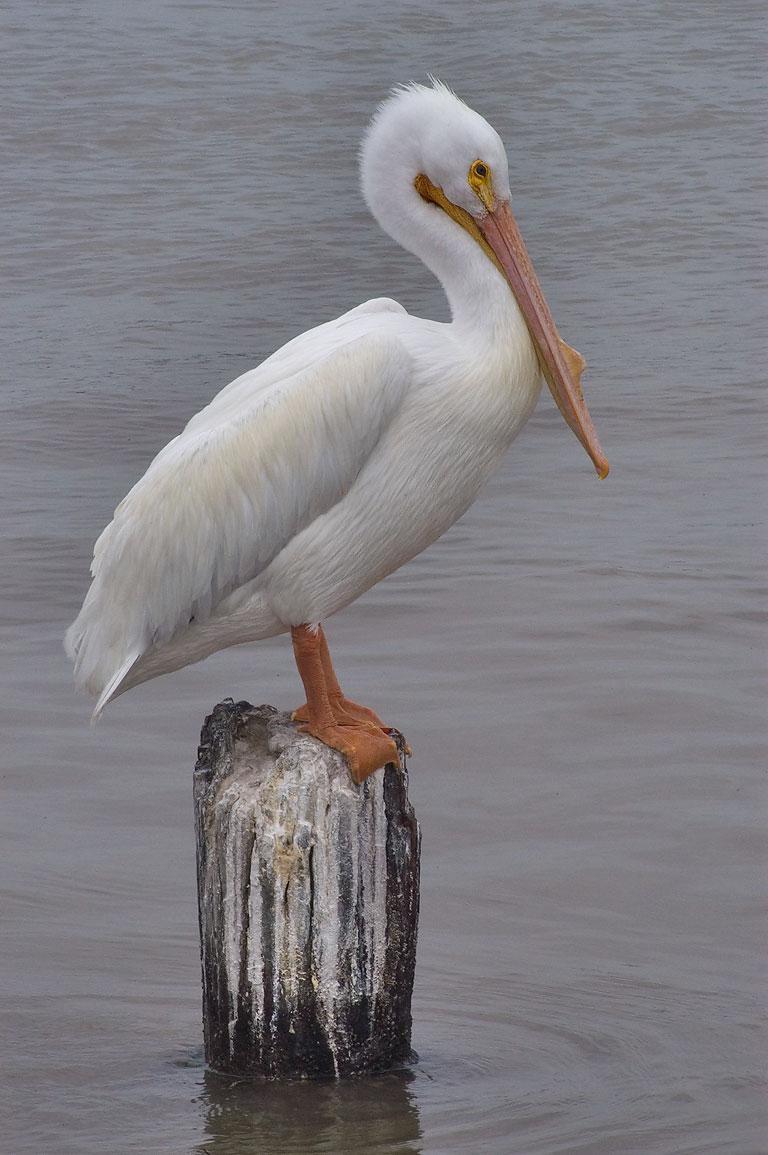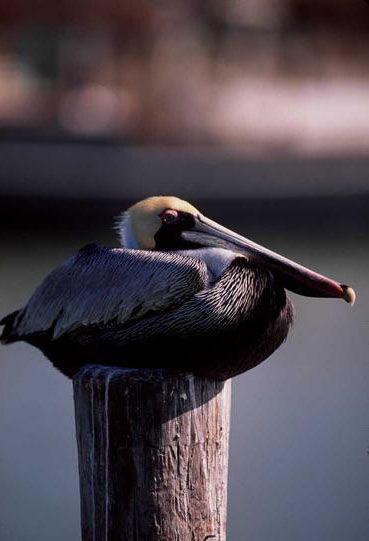The first image is the image on the left, the second image is the image on the right. Examine the images to the left and right. Is the description "There's no more than two birds." accurate? Answer yes or no. Yes. The first image is the image on the left, the second image is the image on the right. Examine the images to the left and right. Is the description "One image shows a single white bird tucked into an egg shape, and the other shows a group of black-and-white birds with necks tucked backward." accurate? Answer yes or no. No. 